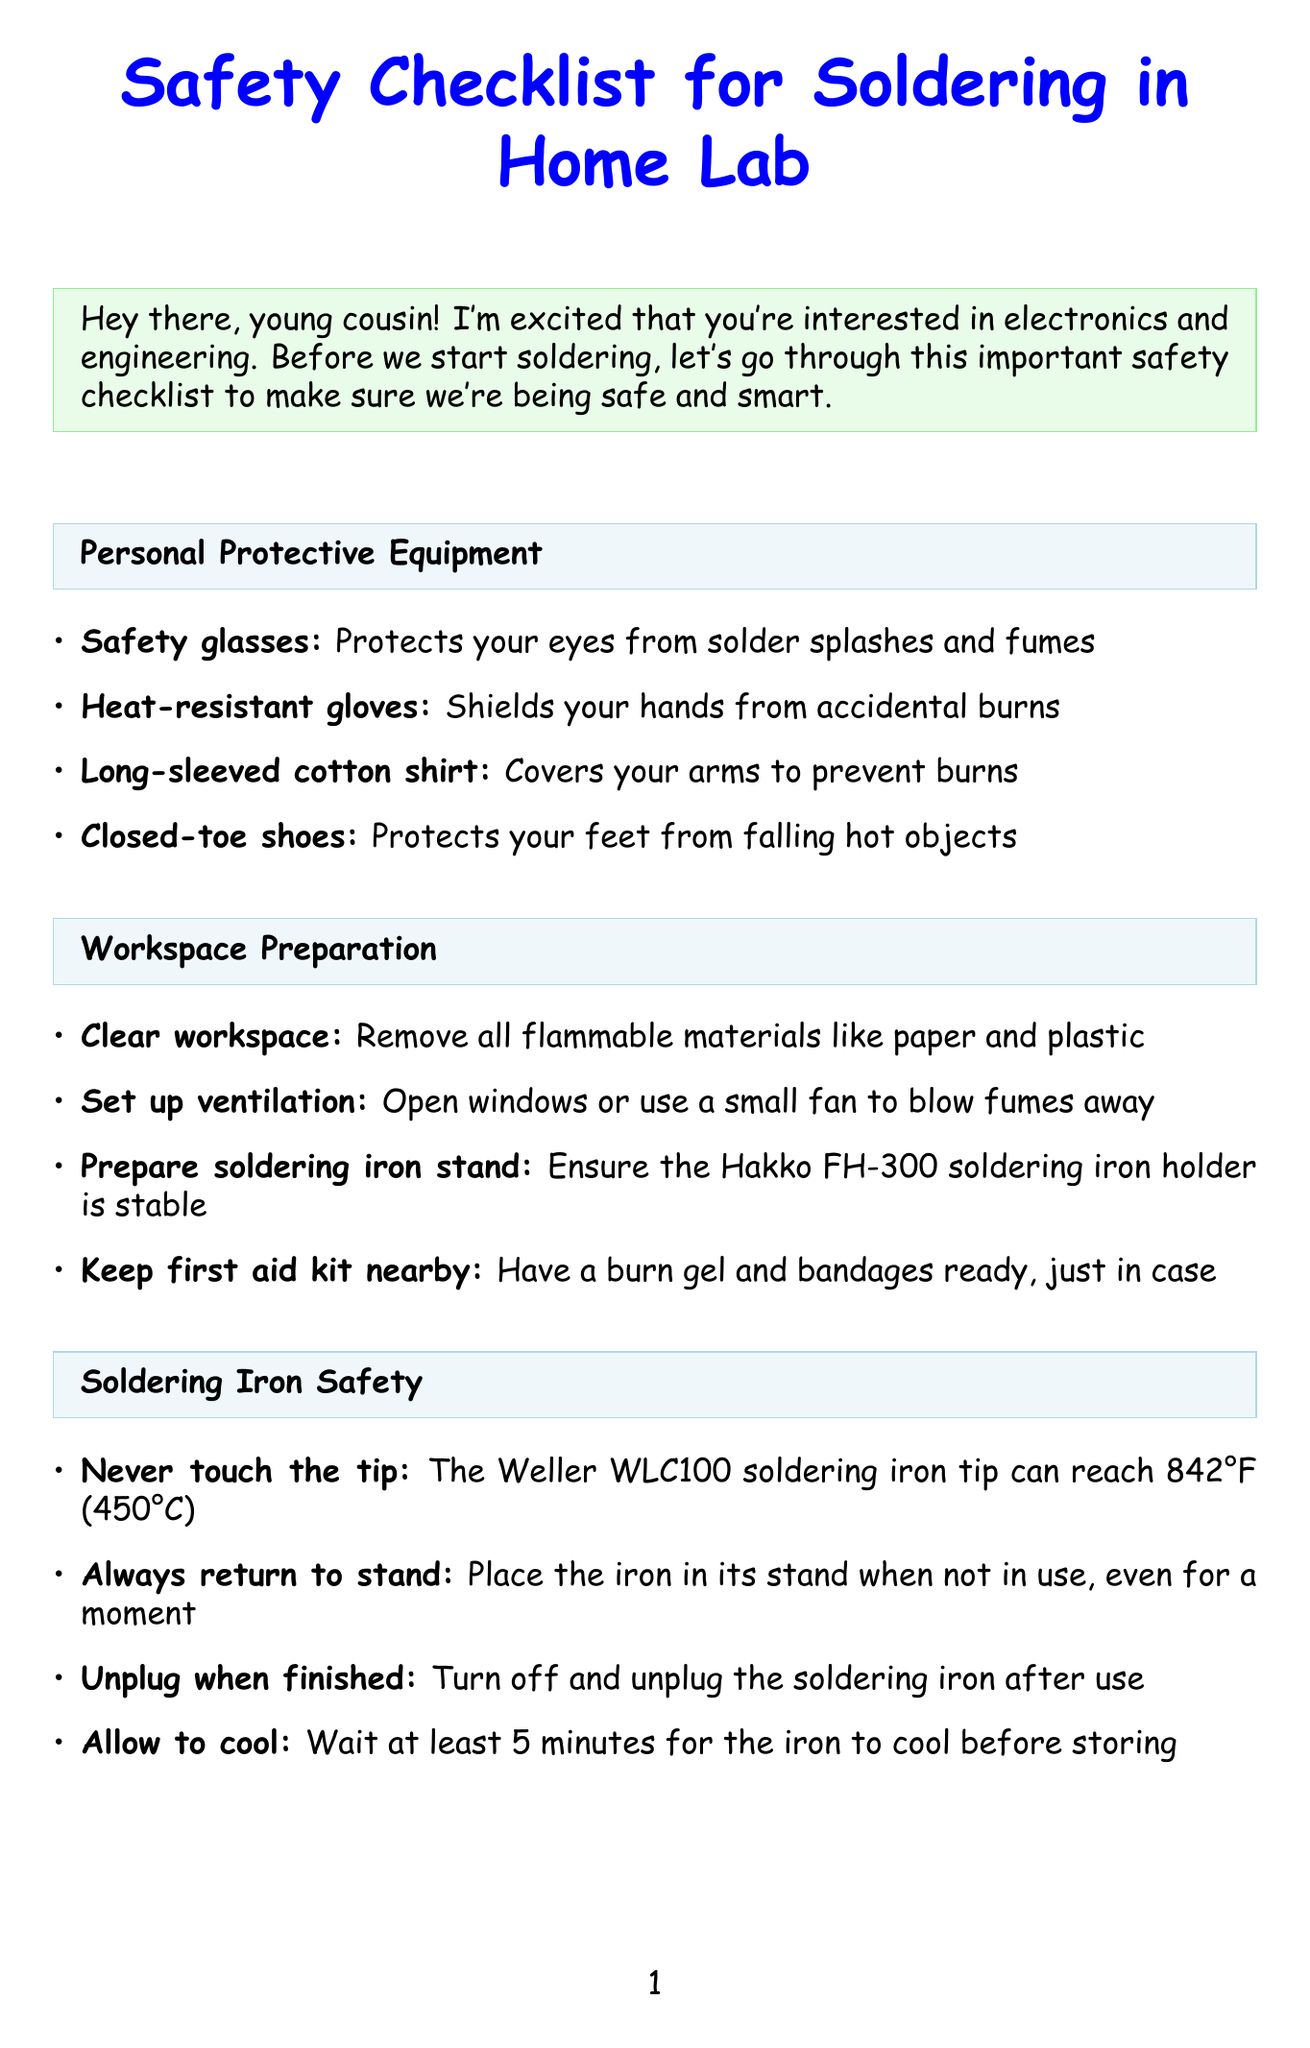What is the title of the document? The title directly indicates the purpose of the document, which is to outline safety protocols.
Answer: Safety Checklist for Soldering in Home Lab How many items are in the personal protective equipment section? The number of items listed helps to understand the necessary gear for safety.
Answer: 4 What should be used as a fire extinguisher for electrical fires? The document specifies the appropriate type of fire extinguisher to use in an emergency.
Answer: Class C fire extinguisher What action should you take after soldering? This involves personal hygiene and safety practices outlined in the document.
Answer: Wash hands after soldering What is the maximum temperature of the soldering iron tip? This indicates the importance of handling soldering equipment carefully given its high temperature.
Answer: 842°F (450°C) Why should you use lead-free solder? The reasoning emphasizes safety concerns for beginners.
Answer: Safer for beginners What is the recommended action if solder comes in contact with eyes? This specifies emergency procedures in case of an accident.
Answer: Flush eyes with water for 15 minutes What type of shirt should be worn while soldering? The specific clothing requirement is outlined for protection against burns.
Answer: Long-sleeved cotton shirt 